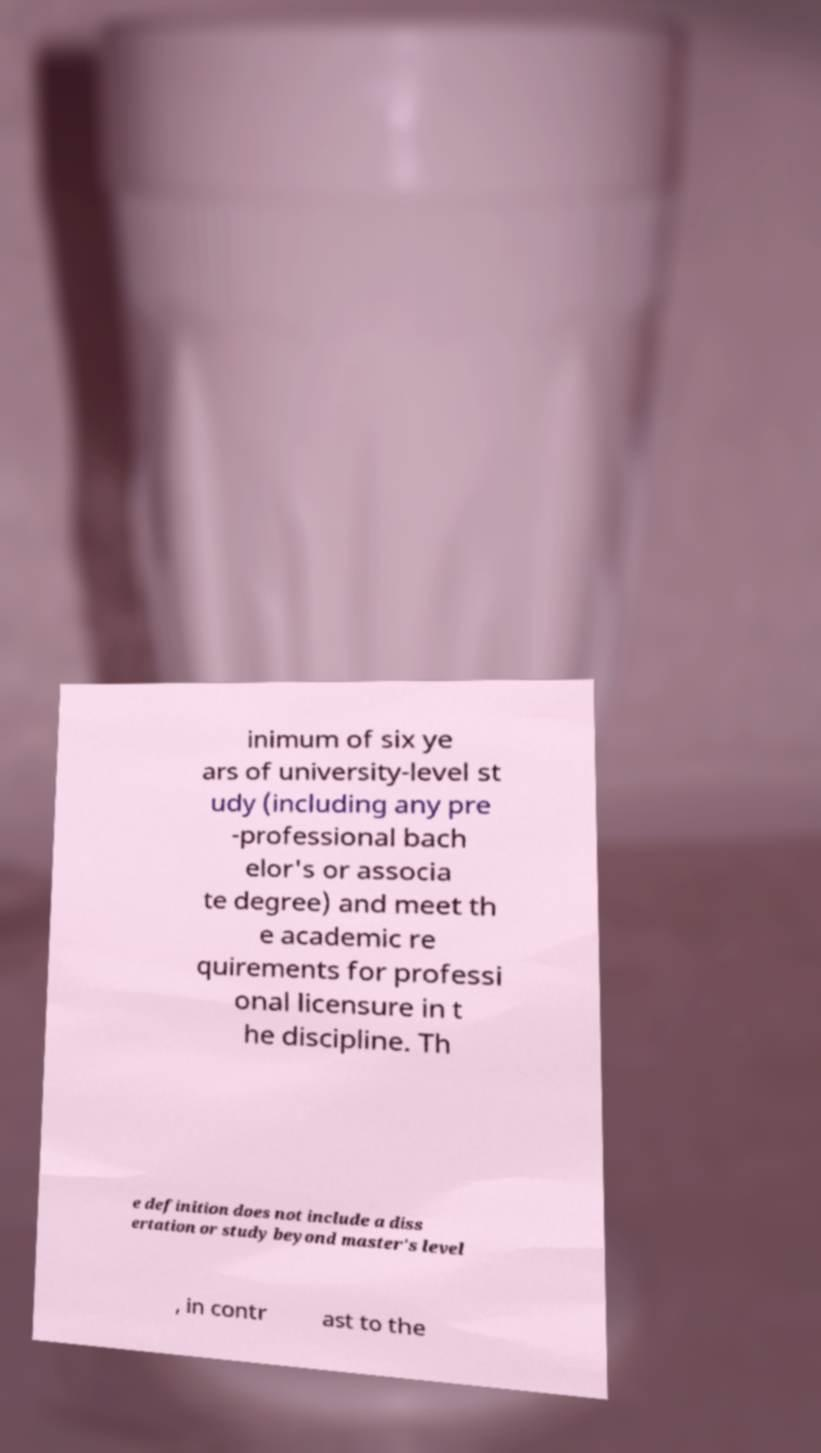Please identify and transcribe the text found in this image. inimum of six ye ars of university-level st udy (including any pre -professional bach elor's or associa te degree) and meet th e academic re quirements for professi onal licensure in t he discipline. Th e definition does not include a diss ertation or study beyond master's level , in contr ast to the 